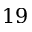Convert formula to latex. <formula><loc_0><loc_0><loc_500><loc_500>1 9</formula> 